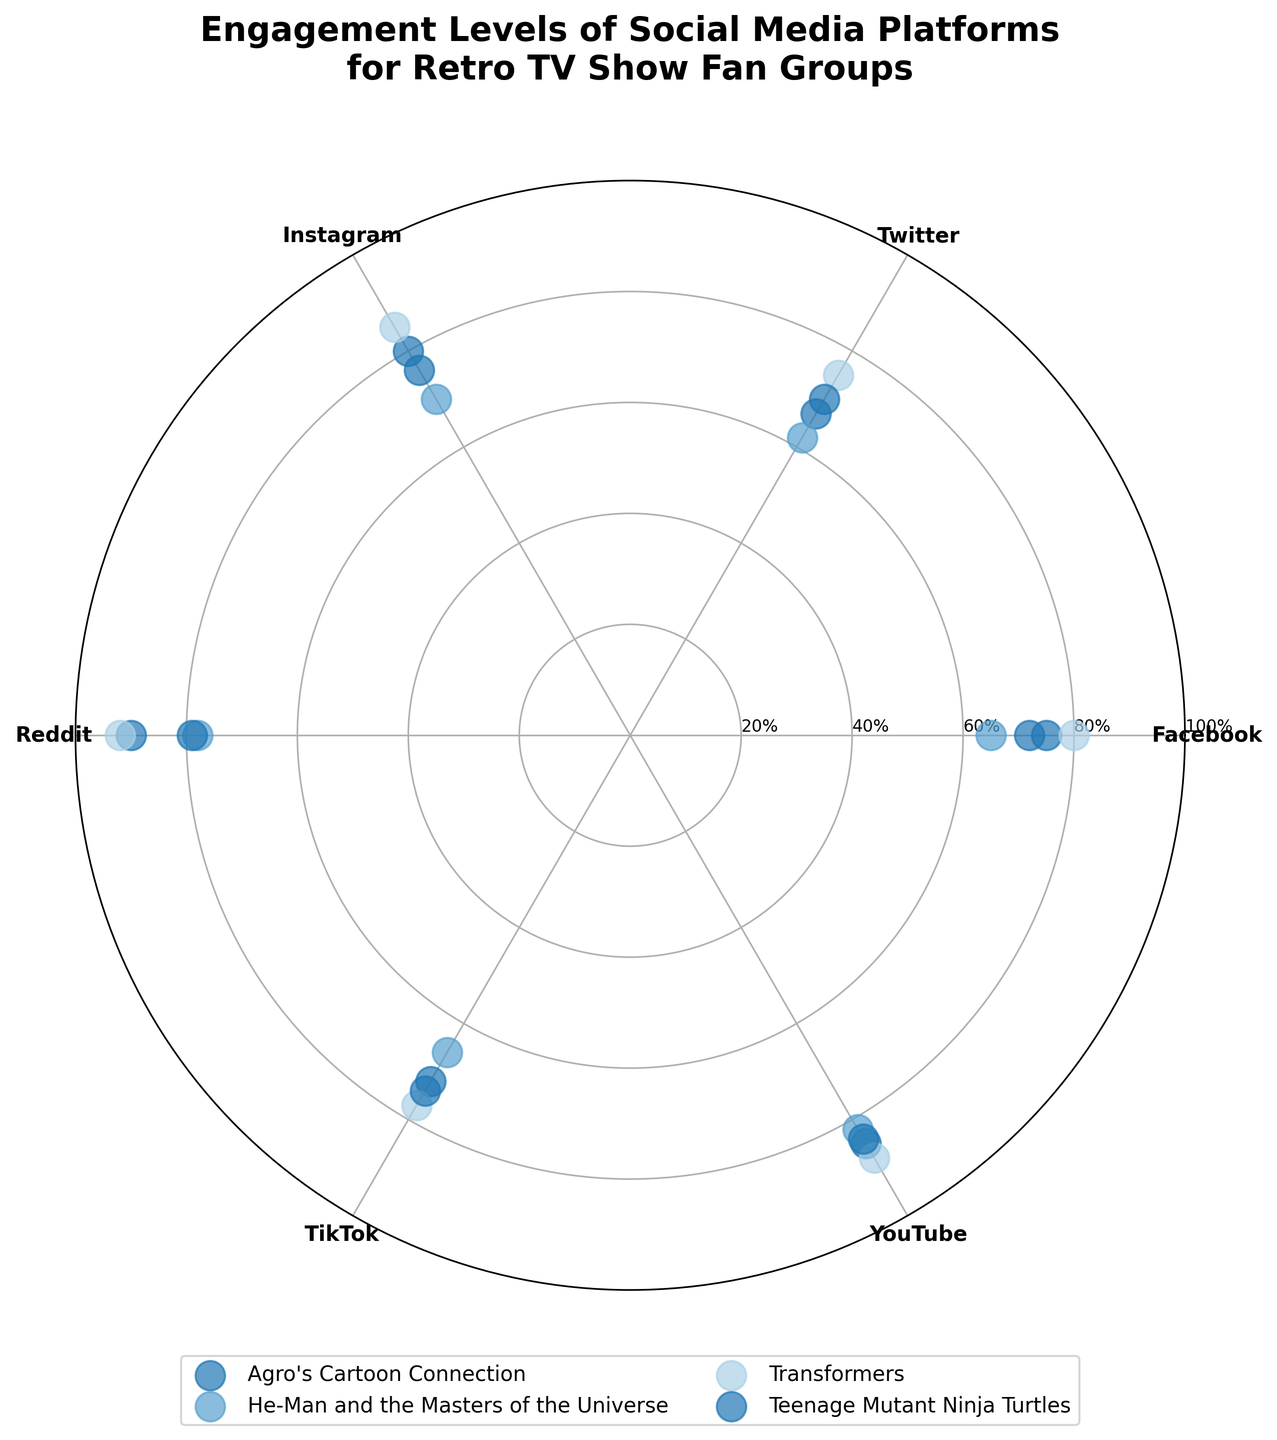What is the title of the plot? The title of the plot is displayed at the top center of the figure. It states "Engagement Levels of Social Media Platforms for Retro TV Show Fan Groups."
Answer: Engagement Levels of Social Media Platforms for Retro TV Show Fan Groups Which social media platform has the highest engagement level for Agro's Cartoon Connection? By looking at the scatter points for Agro's Cartoon Connection, we can see that Reddit has the highest engagement level.
Answer: Reddit How many social media platforms are analyzed in the plot? There are six unique scatter points around the polar plot, representing different social media platforms.
Answer: 6 Which retro TV show has the highest engagement on YouTube? By checking the scatter point on the angle corresponding to YouTube, it's observed that Transformers has the highest engagement level.
Answer: Transformers What is the range of engagement levels for He-Man and the Masters of the Universe across all social media platforms? The engagement levels for He-Man and the Masters of the Universe range from 62 (Twitter) to 82 (YouTube).
Answer: 62 to 82 How much higher is the engagement level on Reddit for Transformers compared to Teenage Mutant Ninja Turtles? The engagement level for Transformers on Reddit is 92, while for Teenage Mutant Ninja Turtles, it's 79. The difference is 92 - 79 = 13.
Answer: 13 Which social media platforms have an engagement level above 80 for Agro's Cartoon Connection? By checking the scatter points for Agro's Cartoon Connection, we can see that Instagram (80), Reddit (90), and YouTube (85) have engagement levels above 80.
Answer: Instagram, Reddit, YouTube Between TikTok and Instagram, which platform has a higher engagement level for every retro TV show? Comparing the scatter points for TikTok and Instagram across all shows: 
- Agro's Cartoon Connection: Instagram > TikTok 
- He-Man: Instagram > TikTok 
- Transformers: Instagram > TikTok 
- Teenage Mutant Ninja Turtles: Instagram > TikTok 
Thus, Instagram has higher engagement for every show.
Answer: Instagram 